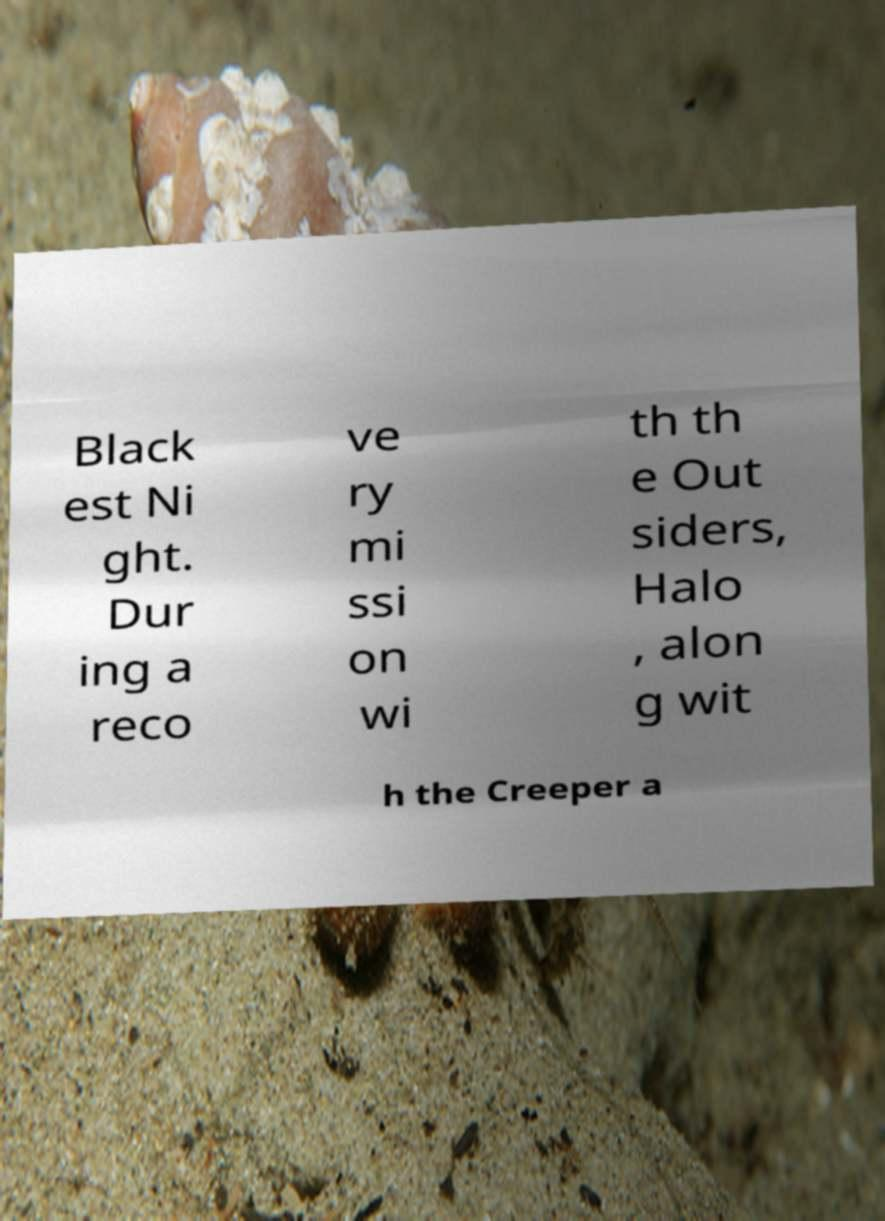Please read and relay the text visible in this image. What does it say? Black est Ni ght. Dur ing a reco ve ry mi ssi on wi th th e Out siders, Halo , alon g wit h the Creeper a 